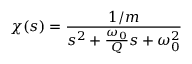<formula> <loc_0><loc_0><loc_500><loc_500>\chi ( s ) = \frac { 1 / m } { s ^ { 2 } + \frac { \omega _ { 0 } } { Q } s + \omega _ { 0 } ^ { 2 } }</formula> 